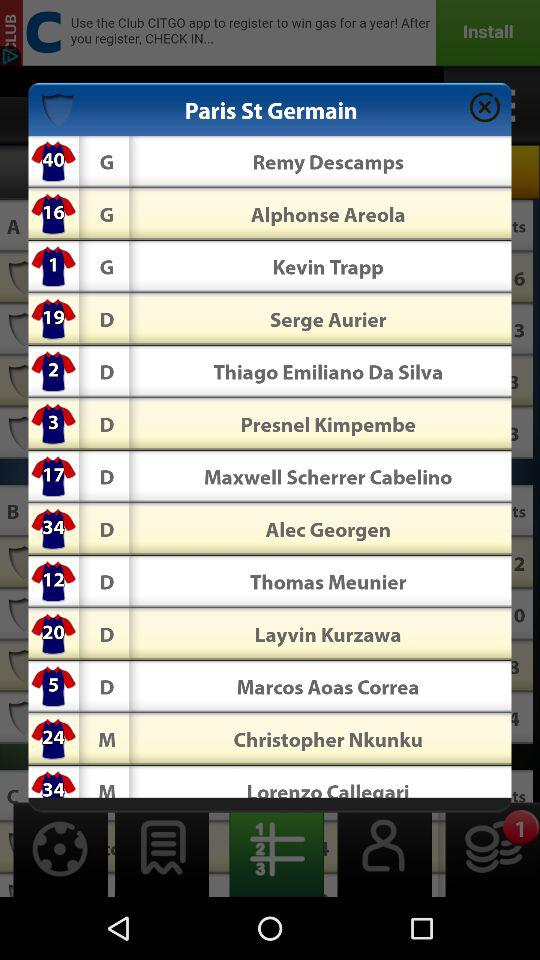What is the jersey number of Kevin Trapp? The jersey number of Kevin Trapp is 1. 